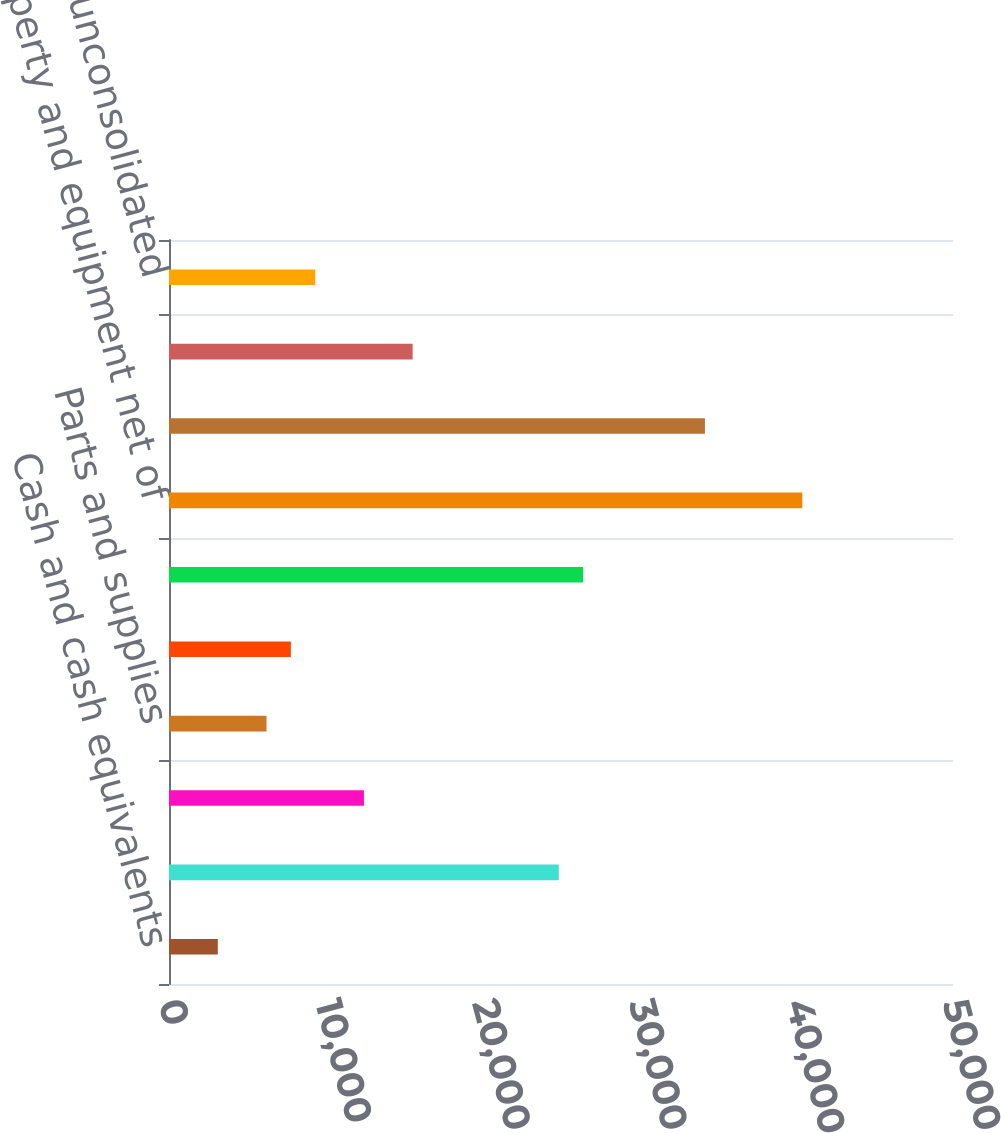<chart> <loc_0><loc_0><loc_500><loc_500><bar_chart><fcel>Cash and cash equivalents<fcel>Accounts receivable net of<fcel>Other receivables<fcel>Parts and supplies<fcel>Other assets<fcel>Total current assets<fcel>Property and equipment net of<fcel>Goodwill<fcel>Other intangible assets net<fcel>Investments in unconsolidated<nl><fcel>3112.6<fcel>24858.8<fcel>12432.4<fcel>6219.2<fcel>7772.5<fcel>26412.1<fcel>40391.8<fcel>34178.6<fcel>15539<fcel>9325.8<nl></chart> 